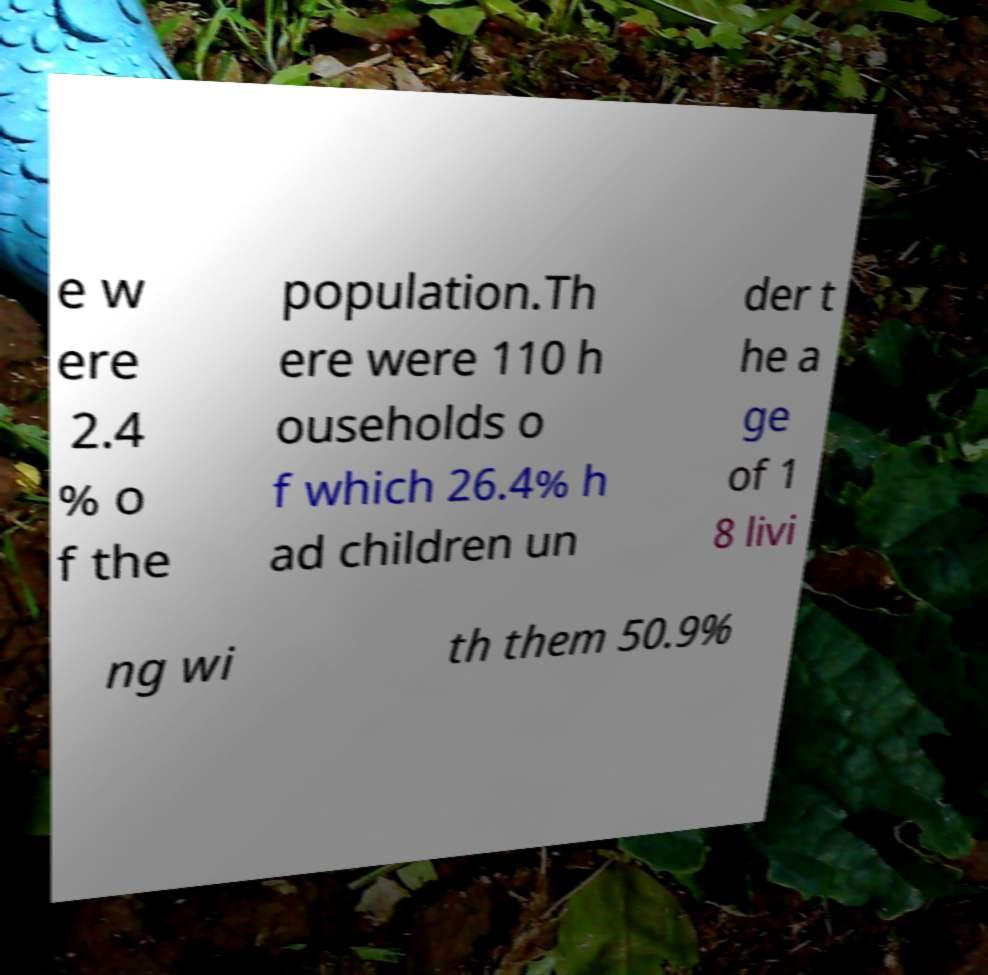For documentation purposes, I need the text within this image transcribed. Could you provide that? e w ere 2.4 % o f the population.Th ere were 110 h ouseholds o f which 26.4% h ad children un der t he a ge of 1 8 livi ng wi th them 50.9% 